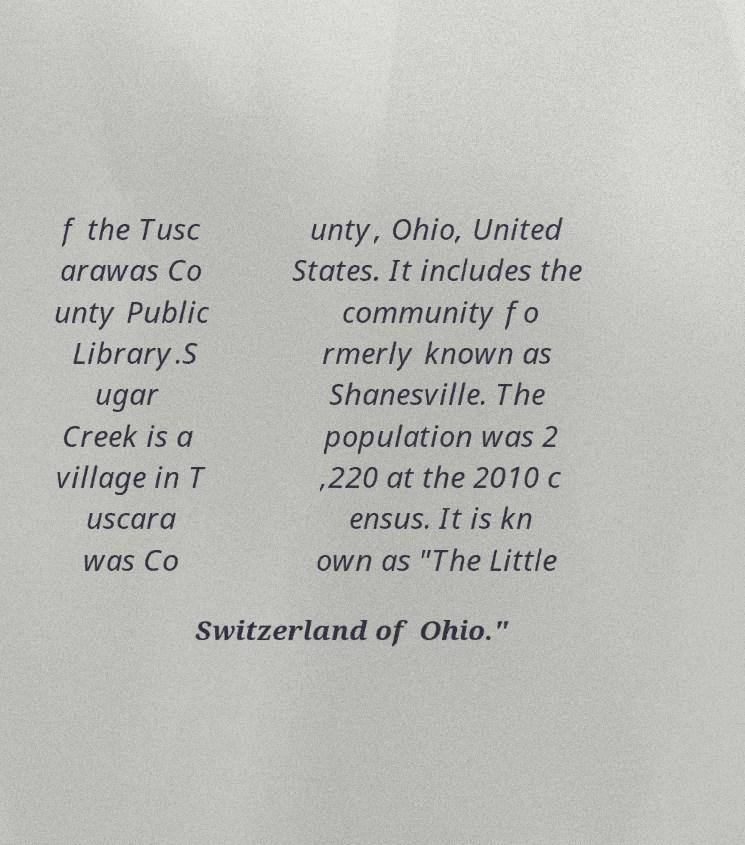There's text embedded in this image that I need extracted. Can you transcribe it verbatim? f the Tusc arawas Co unty Public Library.S ugar Creek is a village in T uscara was Co unty, Ohio, United States. It includes the community fo rmerly known as Shanesville. The population was 2 ,220 at the 2010 c ensus. It is kn own as "The Little Switzerland of Ohio." 